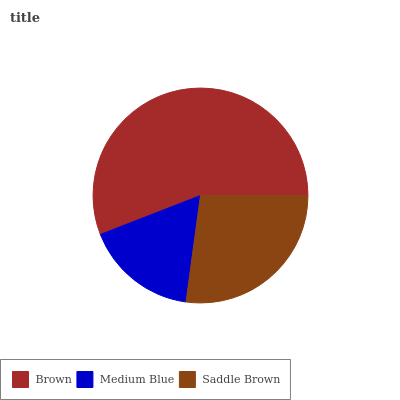Is Medium Blue the minimum?
Answer yes or no. Yes. Is Brown the maximum?
Answer yes or no. Yes. Is Saddle Brown the minimum?
Answer yes or no. No. Is Saddle Brown the maximum?
Answer yes or no. No. Is Saddle Brown greater than Medium Blue?
Answer yes or no. Yes. Is Medium Blue less than Saddle Brown?
Answer yes or no. Yes. Is Medium Blue greater than Saddle Brown?
Answer yes or no. No. Is Saddle Brown less than Medium Blue?
Answer yes or no. No. Is Saddle Brown the high median?
Answer yes or no. Yes. Is Saddle Brown the low median?
Answer yes or no. Yes. Is Brown the high median?
Answer yes or no. No. Is Brown the low median?
Answer yes or no. No. 